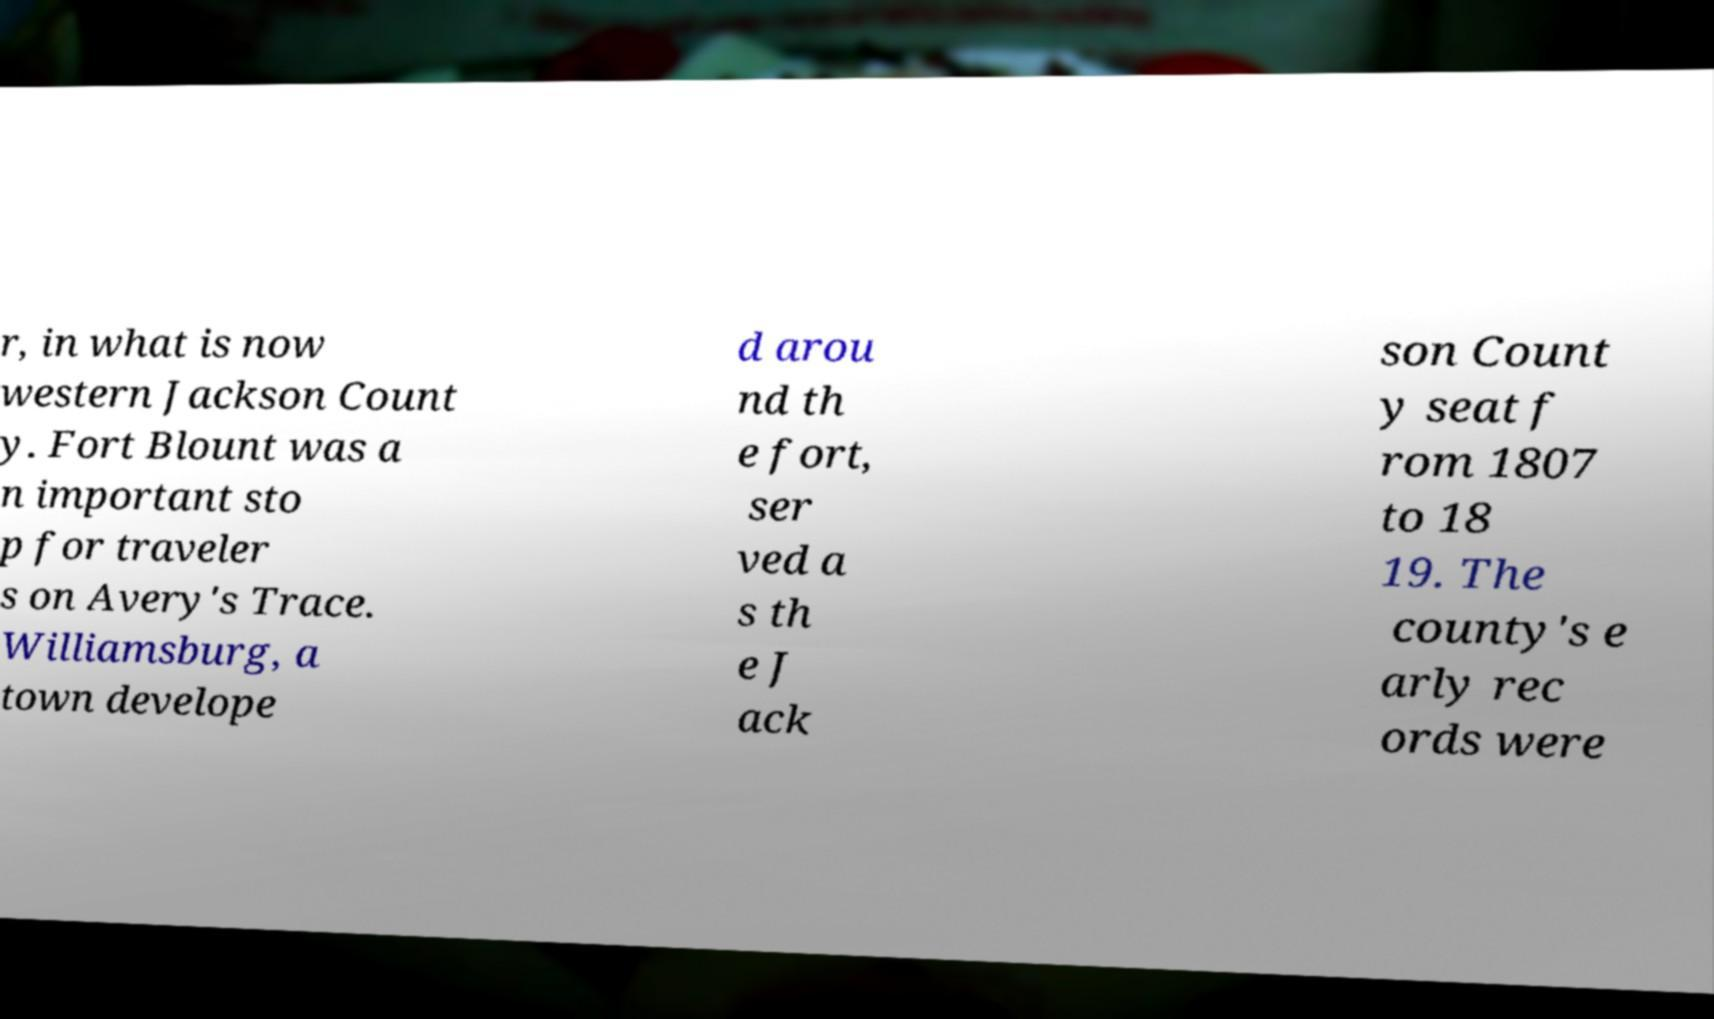Could you extract and type out the text from this image? r, in what is now western Jackson Count y. Fort Blount was a n important sto p for traveler s on Avery's Trace. Williamsburg, a town develope d arou nd th e fort, ser ved a s th e J ack son Count y seat f rom 1807 to 18 19. The county's e arly rec ords were 